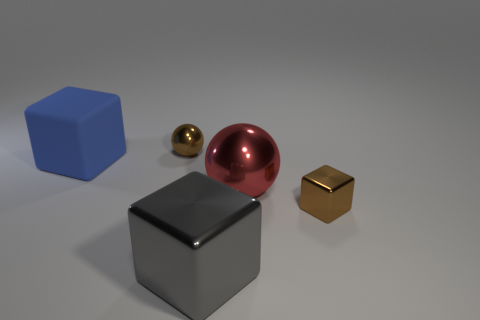Subtract all tiny cubes. How many cubes are left? 2 Subtract all blue blocks. How many blocks are left? 2 Add 2 red shiny objects. How many objects exist? 7 Subtract 1 gray blocks. How many objects are left? 4 Subtract all blocks. How many objects are left? 2 Subtract 2 blocks. How many blocks are left? 1 Subtract all gray cubes. Subtract all gray cylinders. How many cubes are left? 2 Subtract all purple cylinders. How many blue blocks are left? 1 Subtract all small rubber cylinders. Subtract all small metal things. How many objects are left? 3 Add 4 tiny brown blocks. How many tiny brown blocks are left? 5 